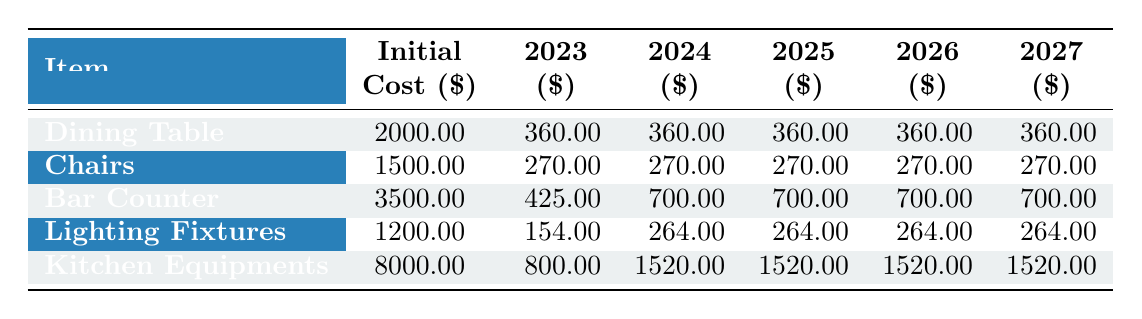What is the initial cost of the Dining Table? The initial cost for the Dining Table is listed directly in the table under the "Initial Cost ($)" column, which shows $2000.00.
Answer: 2000.00 In which year is the annual depreciation for Lighting Fixtures higher, 2023 or 2024? The annual depreciation for Lighting Fixtures is $154.00 in 2023 and $264.00 in 2024. Since $264.00 is higher than $154.00, 2024 has the higher depreciation.
Answer: 2024 What is the total depreciation for Bar Counter over the 5 years? To find the total depreciation over the 5 years for Bar Counter, we add up the annual depreciations: $425.00 (2023) + $700.00 (2024) + $700.00 (2025) + $700.00 (2026) + $700.00 (2027) = $3,425.00.
Answer: 3425.00 Is the monthly depreciation for Chairs greater than that of Lighting Fixtures? The monthly depreciation for Chairs is $22.50, while for Lighting Fixtures it is $22.00. Since $22.50 is greater than $22.00, the answer is yes.
Answer: Yes What is the average annual depreciation for all items in 2025? In 2025, the annual depreciations are: Dining Table $360.00, Chairs $270.00, Bar Counter $700.00, Lighting Fixtures $264.00, and Kitchen Equipments $1520.00. Sum these values: $360 + $270 + $700 + $264 + $1520 = $3074. Divide by the number of items (5) to find the average: $3074 / 5 = $614.80.
Answer: 614.80 